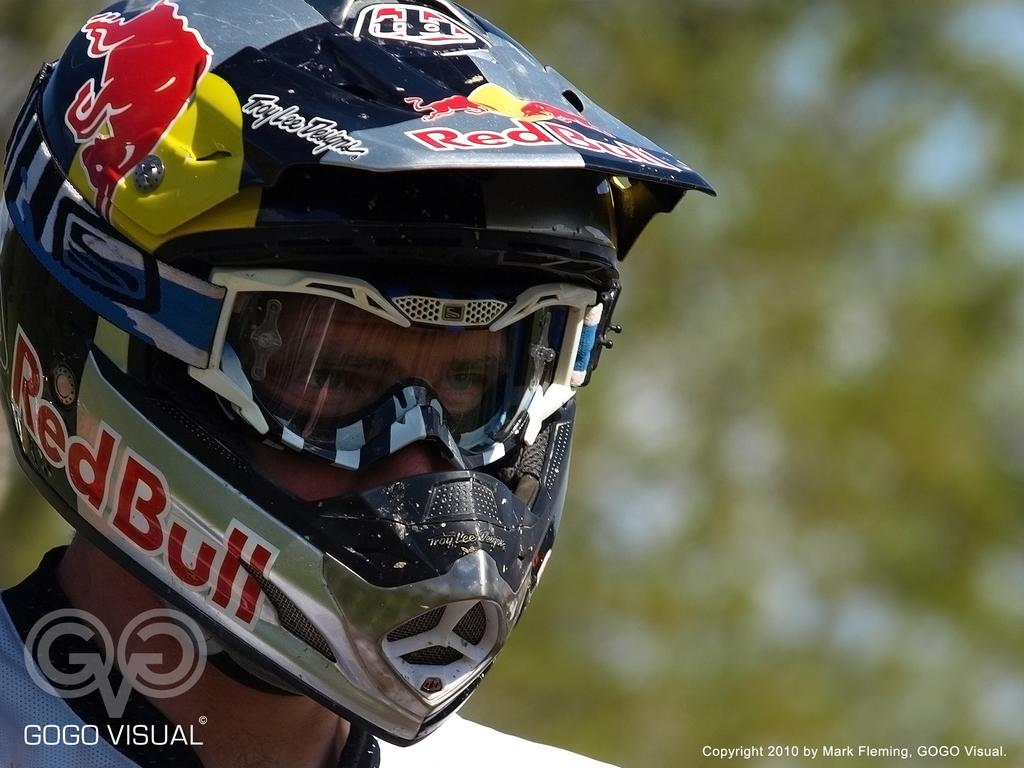Who or what is present in the image? There is a person in the image. What is the person wearing on their head? The person is wearing a bike helmet. What detail can be observed about the bike helmet? The bike helmet is in a different color. How many brushes are being used by the person in the image? There is no brush present in the image. What is the amount of kick the person is giving in the image? There is no kick being given by the person in the image. 